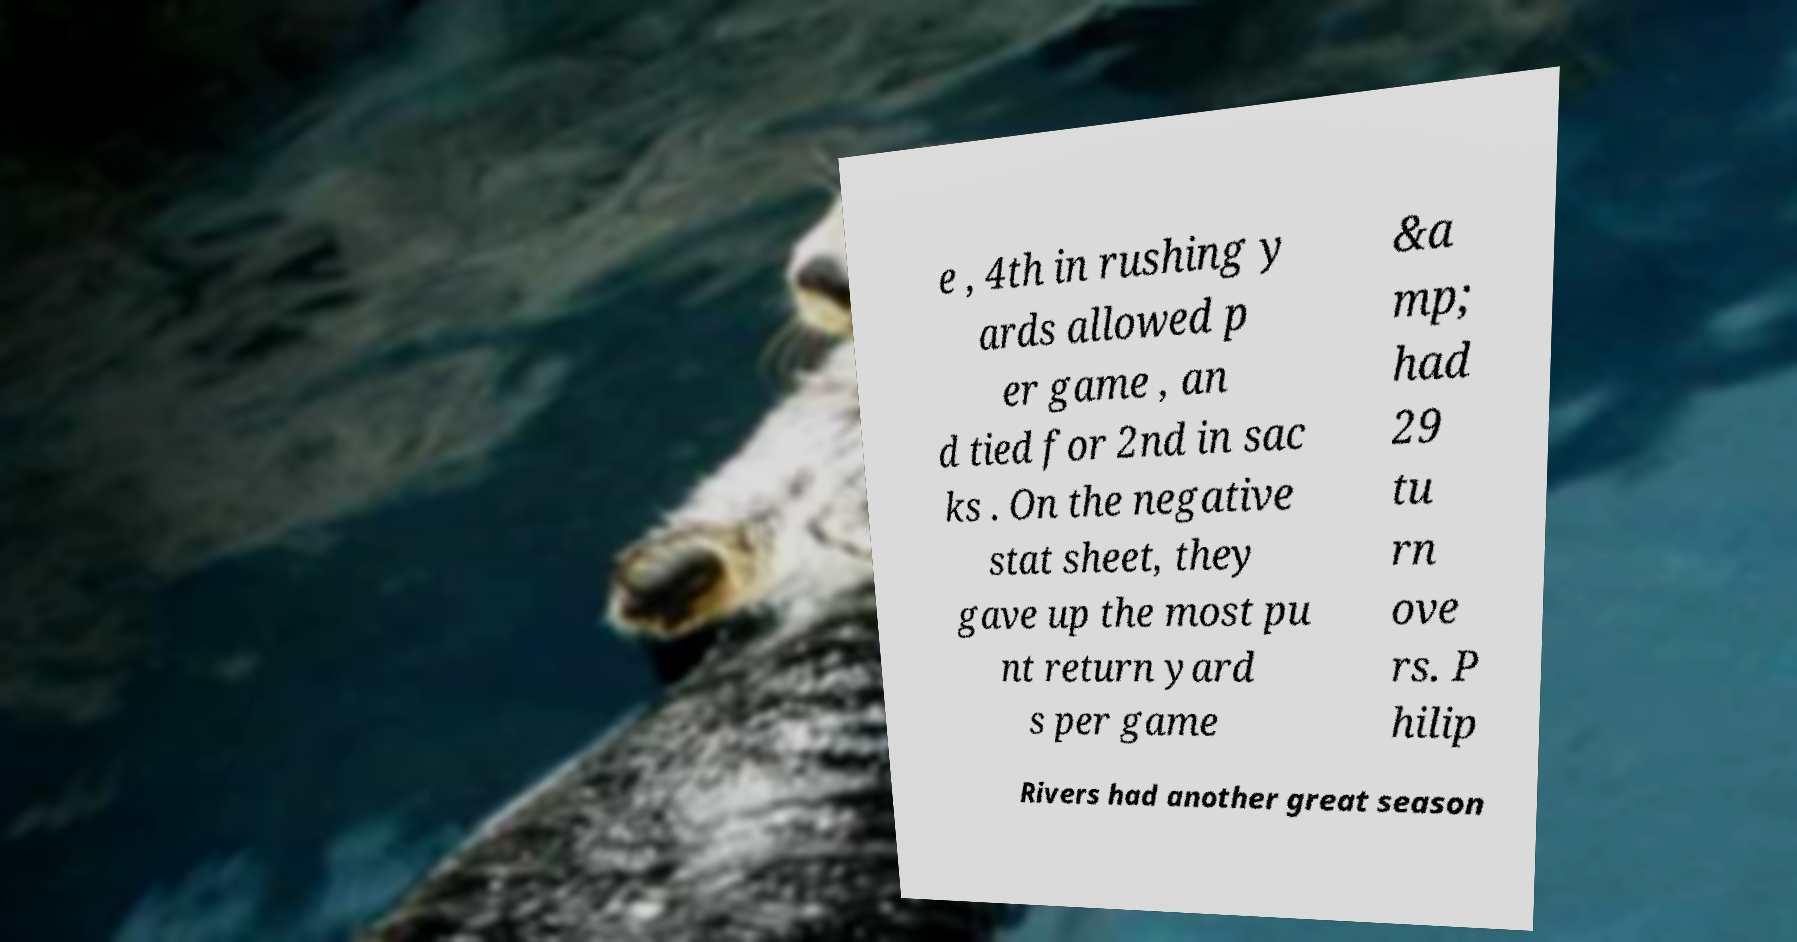Please read and relay the text visible in this image. What does it say? e , 4th in rushing y ards allowed p er game , an d tied for 2nd in sac ks . On the negative stat sheet, they gave up the most pu nt return yard s per game &a mp; had 29 tu rn ove rs. P hilip Rivers had another great season 